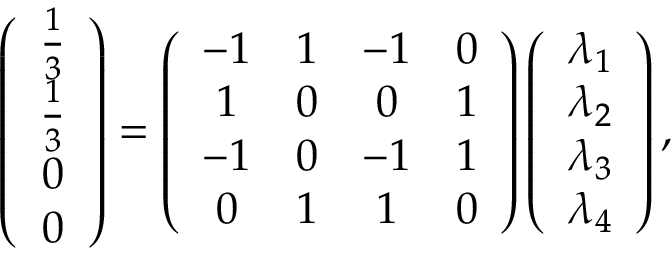Convert formula to latex. <formula><loc_0><loc_0><loc_500><loc_500>\left ( \begin{array} { c } { \frac { 1 } { 3 } } \\ { \frac { 1 } { 3 } } \\ { 0 } \\ { 0 } \end{array} \right ) = \left ( \begin{array} { c c c c } { - 1 } & { 1 } & { - 1 } & { 0 } \\ { 1 } & { 0 } & { 0 } & { 1 } \\ { - 1 } & { 0 } & { - 1 } & { 1 } \\ { 0 } & { 1 } & { 1 } & { 0 } \end{array} \right ) \left ( \begin{array} { c } { \lambda _ { 1 } } \\ { \lambda _ { 2 } } \\ { \lambda _ { 3 } } \\ { \lambda _ { 4 } } \end{array} \right ) ,</formula> 